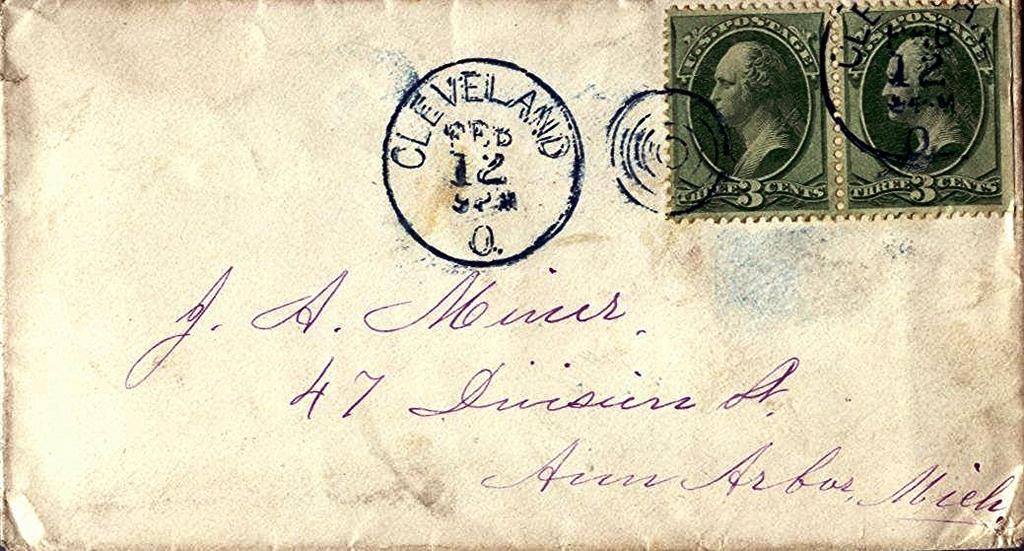<image>
Write a terse but informative summary of the picture. A letter is postmarked as being sent from Cleveland. 